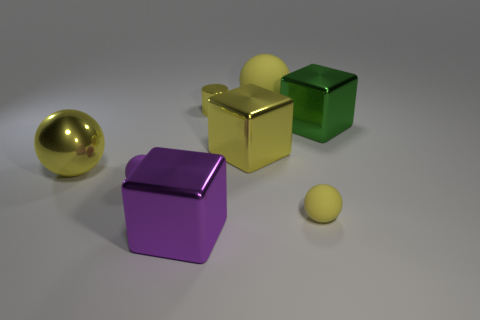Add 1 purple balls. How many objects exist? 9 Subtract all tiny purple spheres. How many spheres are left? 3 Subtract all blocks. How many objects are left? 5 Subtract 2 cubes. How many cubes are left? 1 Subtract all metal balls. Subtract all large purple blocks. How many objects are left? 6 Add 8 large green things. How many large green things are left? 9 Add 7 tiny purple rubber objects. How many tiny purple rubber objects exist? 8 Subtract all purple spheres. How many spheres are left? 3 Subtract 0 blue spheres. How many objects are left? 8 Subtract all blue cylinders. Subtract all yellow cubes. How many cylinders are left? 1 